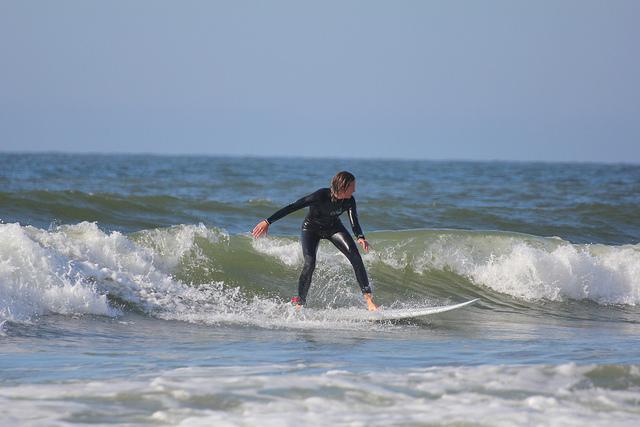How many people are there?
Give a very brief answer. 1. How many apple brand laptops can you see?
Give a very brief answer. 0. 